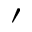<formula> <loc_0><loc_0><loc_500><loc_500>\prime</formula> 